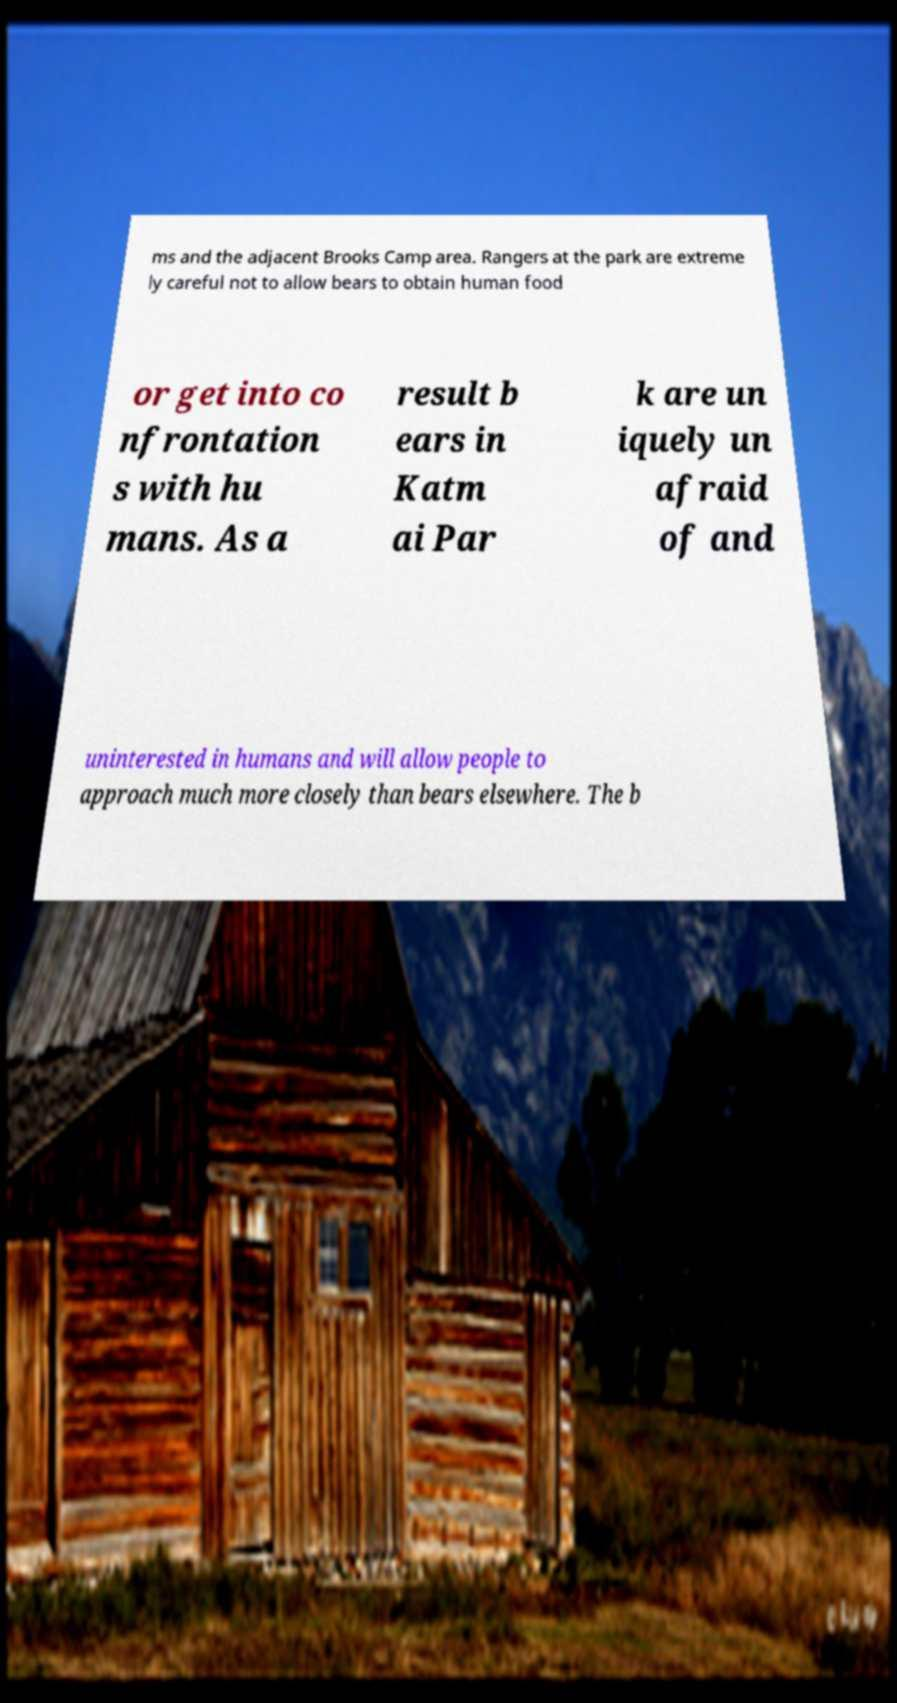For documentation purposes, I need the text within this image transcribed. Could you provide that? ms and the adjacent Brooks Camp area. Rangers at the park are extreme ly careful not to allow bears to obtain human food or get into co nfrontation s with hu mans. As a result b ears in Katm ai Par k are un iquely un afraid of and uninterested in humans and will allow people to approach much more closely than bears elsewhere. The b 